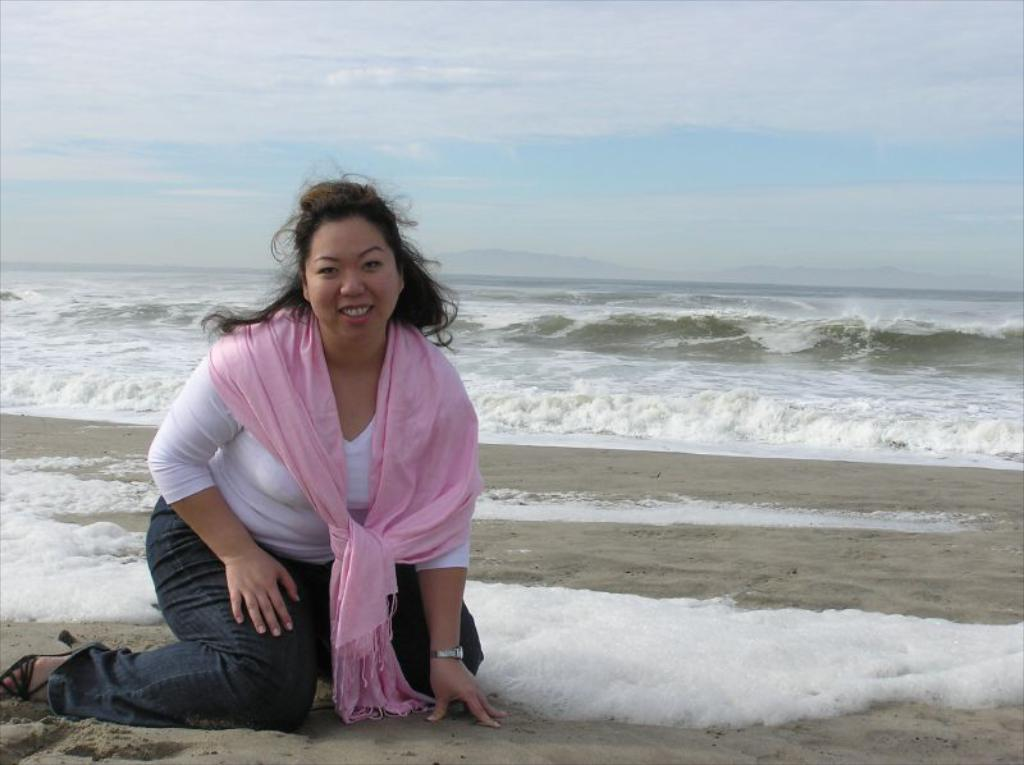Who is the main subject in the image? There is a woman in the image. What is the woman doing in the image? The woman is kneeling down on the ground. What can be seen in the background of the image? Waves and the sky are visible in the image. What color is the scarf that the woman is wearing? The woman is wearing a pink color scarf. What type of cheese is being used to draw on the ground in the image? There is no cheese present in the image, and no drawing activity is taking place. 